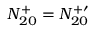<formula> <loc_0><loc_0><loc_500><loc_500>N _ { 2 0 } ^ { + } = N _ { 2 0 } ^ { + \prime }</formula> 